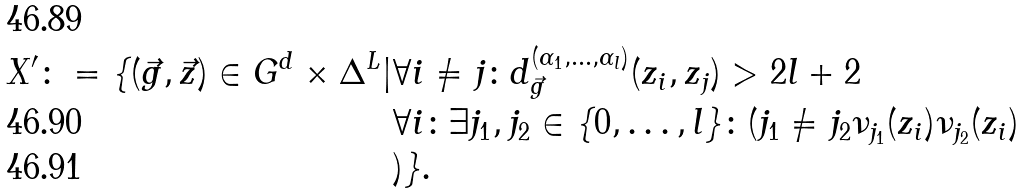<formula> <loc_0><loc_0><loc_500><loc_500>X ^ { \prime } \colon = \{ ( \vec { g } , \vec { z } ) \in G ^ { d } \times \Delta ^ { L } | & \forall i \not = j \colon d _ { \vec { g } } ^ { ( \alpha _ { 1 } , \dots , \alpha _ { l } ) } ( z _ { i } , z _ { j } ) > 2 l + 2 \\ & \forall i \colon \exists j _ { 1 } , j _ { 2 } \in \{ 0 , \dots , l \} \colon ( j _ { 1 } \not = j _ { 2 } \nu _ { j _ { 1 } } ( z _ { i } ) \nu _ { j _ { 2 } } ( z _ { i } ) \\ & ) \} .</formula> 